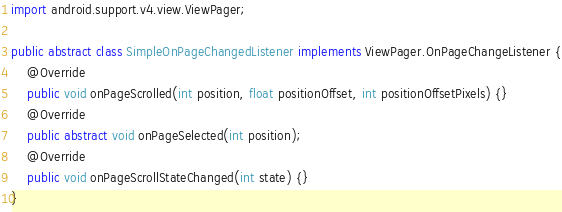Convert code to text. <code><loc_0><loc_0><loc_500><loc_500><_Java_>
import android.support.v4.view.ViewPager;

public abstract class SimpleOnPageChangedListener implements ViewPager.OnPageChangeListener {
    @Override
    public void onPageScrolled(int position, float positionOffset, int positionOffsetPixels) {}
    @Override
    public abstract void onPageSelected(int position);
    @Override
    public void onPageScrollStateChanged(int state) {}
}</code> 